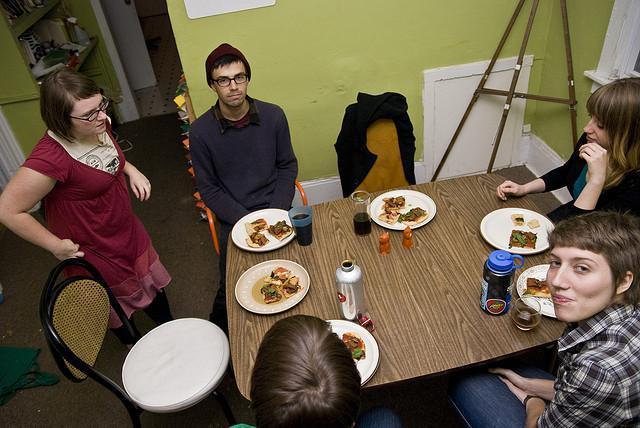How many plates are on the table?
Give a very brief answer. 6. How many chairs are there?
Give a very brief answer. 2. How many people are there?
Give a very brief answer. 5. How many tracks have no trains on them?
Give a very brief answer. 0. 